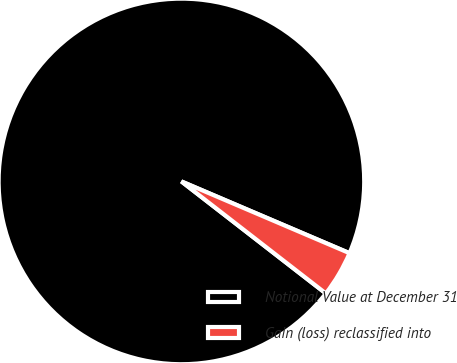Convert chart. <chart><loc_0><loc_0><loc_500><loc_500><pie_chart><fcel>Notional Value at December 31<fcel>Gain (loss) reclassified into<nl><fcel>95.92%<fcel>4.08%<nl></chart> 